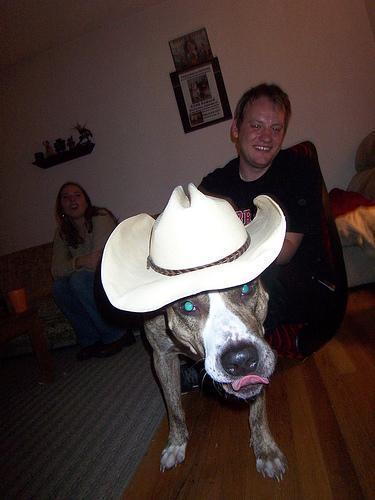How many people are shown?
Give a very brief answer. 2. 